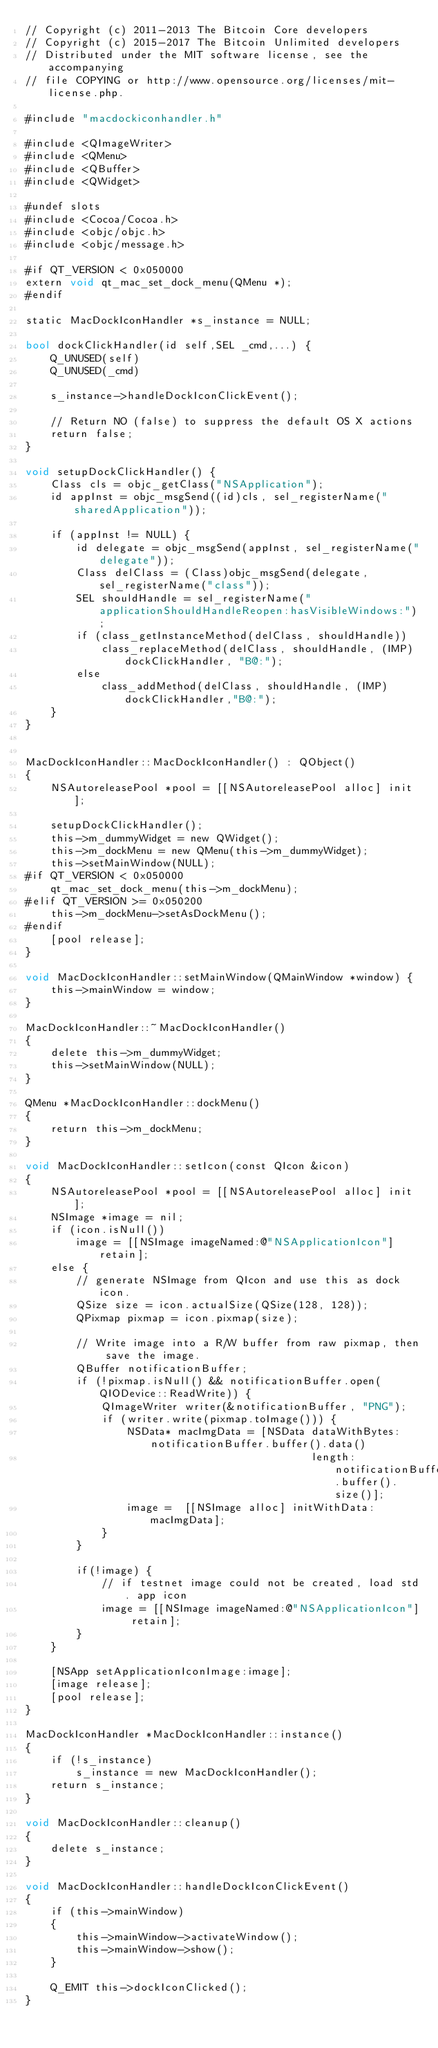Convert code to text. <code><loc_0><loc_0><loc_500><loc_500><_ObjectiveC_>// Copyright (c) 2011-2013 The Bitcoin Core developers
// Copyright (c) 2015-2017 The Bitcoin Unlimited developers
// Distributed under the MIT software license, see the accompanying
// file COPYING or http://www.opensource.org/licenses/mit-license.php.

#include "macdockiconhandler.h"

#include <QImageWriter>
#include <QMenu>
#include <QBuffer>
#include <QWidget>

#undef slots
#include <Cocoa/Cocoa.h>
#include <objc/objc.h>
#include <objc/message.h>

#if QT_VERSION < 0x050000
extern void qt_mac_set_dock_menu(QMenu *);
#endif

static MacDockIconHandler *s_instance = NULL;

bool dockClickHandler(id self,SEL _cmd,...) {
    Q_UNUSED(self)
    Q_UNUSED(_cmd)
    
    s_instance->handleDockIconClickEvent();
    
    // Return NO (false) to suppress the default OS X actions
    return false;
}

void setupDockClickHandler() {
    Class cls = objc_getClass("NSApplication");
    id appInst = objc_msgSend((id)cls, sel_registerName("sharedApplication"));
    
    if (appInst != NULL) {
        id delegate = objc_msgSend(appInst, sel_registerName("delegate"));
        Class delClass = (Class)objc_msgSend(delegate,  sel_registerName("class"));
        SEL shouldHandle = sel_registerName("applicationShouldHandleReopen:hasVisibleWindows:");
        if (class_getInstanceMethod(delClass, shouldHandle))
            class_replaceMethod(delClass, shouldHandle, (IMP)dockClickHandler, "B@:");
        else
            class_addMethod(delClass, shouldHandle, (IMP)dockClickHandler,"B@:");
    }
}


MacDockIconHandler::MacDockIconHandler() : QObject()
{
    NSAutoreleasePool *pool = [[NSAutoreleasePool alloc] init];

    setupDockClickHandler();
    this->m_dummyWidget = new QWidget();
    this->m_dockMenu = new QMenu(this->m_dummyWidget);
    this->setMainWindow(NULL);
#if QT_VERSION < 0x050000
    qt_mac_set_dock_menu(this->m_dockMenu);
#elif QT_VERSION >= 0x050200
    this->m_dockMenu->setAsDockMenu();
#endif
    [pool release];
}

void MacDockIconHandler::setMainWindow(QMainWindow *window) {
    this->mainWindow = window;
}

MacDockIconHandler::~MacDockIconHandler()
{
    delete this->m_dummyWidget;
    this->setMainWindow(NULL);
}

QMenu *MacDockIconHandler::dockMenu()
{
    return this->m_dockMenu;
}

void MacDockIconHandler::setIcon(const QIcon &icon)
{
    NSAutoreleasePool *pool = [[NSAutoreleasePool alloc] init];
    NSImage *image = nil;
    if (icon.isNull())
        image = [[NSImage imageNamed:@"NSApplicationIcon"] retain];
    else {
        // generate NSImage from QIcon and use this as dock icon.
        QSize size = icon.actualSize(QSize(128, 128));
        QPixmap pixmap = icon.pixmap(size);

        // Write image into a R/W buffer from raw pixmap, then save the image.
        QBuffer notificationBuffer;
        if (!pixmap.isNull() && notificationBuffer.open(QIODevice::ReadWrite)) {
            QImageWriter writer(&notificationBuffer, "PNG");
            if (writer.write(pixmap.toImage())) {
                NSData* macImgData = [NSData dataWithBytes:notificationBuffer.buffer().data()
                                             length:notificationBuffer.buffer().size()];
                image =  [[NSImage alloc] initWithData:macImgData];
            }
        }

        if(!image) {
            // if testnet image could not be created, load std. app icon
            image = [[NSImage imageNamed:@"NSApplicationIcon"] retain];
        }
    }

    [NSApp setApplicationIconImage:image];
    [image release];
    [pool release];
}

MacDockIconHandler *MacDockIconHandler::instance()
{
    if (!s_instance)
        s_instance = new MacDockIconHandler();
    return s_instance;
}

void MacDockIconHandler::cleanup()
{
    delete s_instance;
}

void MacDockIconHandler::handleDockIconClickEvent()
{
    if (this->mainWindow)
    {
        this->mainWindow->activateWindow();
        this->mainWindow->show();
    }

    Q_EMIT this->dockIconClicked();
}
</code> 